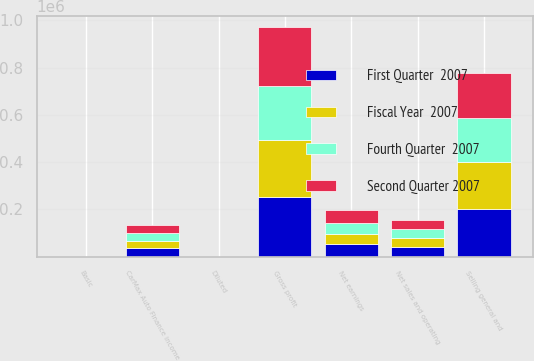<chart> <loc_0><loc_0><loc_500><loc_500><stacked_bar_chart><ecel><fcel>Net sales and operating<fcel>Gross profit<fcel>CarMax Auto Finance income<fcel>Selling general and<fcel>Net earnings<fcel>Basic<fcel>Diluted<nl><fcel>Second Quarter 2007<fcel>39325<fcel>248255<fcel>32394<fcel>186966<fcel>56776<fcel>0.27<fcel>0.27<nl><fcel>First Quarter  2007<fcel>39325<fcel>253365<fcel>36512<fcel>200049<fcel>54264<fcel>0.26<fcel>0.25<nl><fcel>Fourth Quarter  2007<fcel>39325<fcel>228609<fcel>31974<fcel>187318<fcel>45419<fcel>0.21<fcel>0.21<nl><fcel>Fiscal Year  2007<fcel>39325<fcel>240833<fcel>31745<fcel>201835<fcel>42138<fcel>0.2<fcel>0.19<nl></chart> 